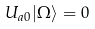<formula> <loc_0><loc_0><loc_500><loc_500>U _ { a 0 } | \Omega \rangle = 0</formula> 